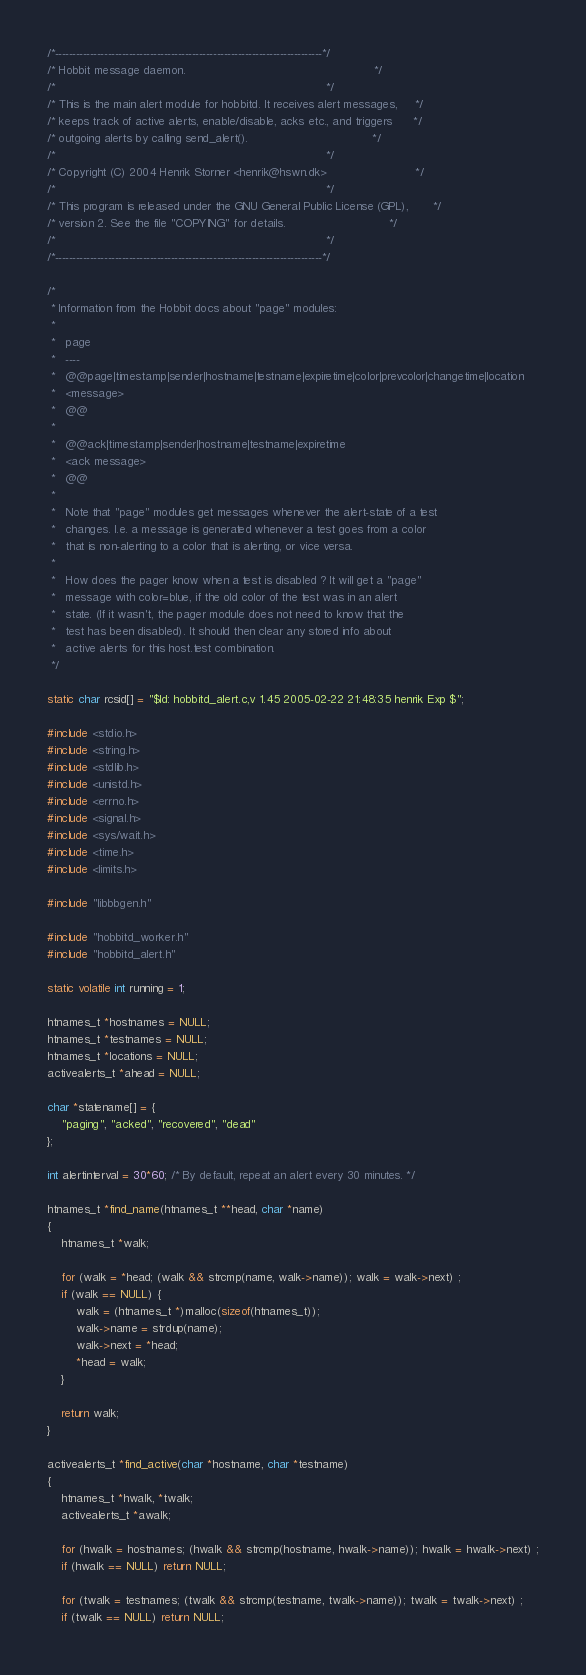Convert code to text. <code><loc_0><loc_0><loc_500><loc_500><_C_>/*----------------------------------------------------------------------------*/
/* Hobbit message daemon.                                                     */
/*                                                                            */
/* This is the main alert module for hobbitd. It receives alert messages,     */
/* keeps track of active alerts, enable/disable, acks etc., and triggers      */
/* outgoing alerts by calling send_alert().                                   */
/*                                                                            */
/* Copyright (C) 2004 Henrik Storner <henrik@hswn.dk>                         */
/*                                                                            */
/* This program is released under the GNU General Public License (GPL),       */
/* version 2. See the file "COPYING" for details.                             */
/*                                                                            */
/*----------------------------------------------------------------------------*/

/*
 * Information from the Hobbit docs about "page" modules:
 *
 *   page
 *   ----
 *   @@page|timestamp|sender|hostname|testname|expiretime|color|prevcolor|changetime|location
 *   <message>
 *   @@
 *
 *   @@ack|timestamp|sender|hostname|testname|expiretime
 *   <ack message>
 *   @@
 *
 *   Note that "page" modules get messages whenever the alert-state of a test
 *   changes. I.e. a message is generated whenever a test goes from a color
 *   that is non-alerting to a color that is alerting, or vice versa.
 *
 *   How does the pager know when a test is disabled ? It will get a "page"
 *   message with color=blue, if the old color of the test was in an alert
 *   state. (If it wasn't, the pager module does not need to know that the
 *   test has been disabled). It should then clear any stored info about
 *   active alerts for this host.test combination.
 */

static char rcsid[] = "$Id: hobbitd_alert.c,v 1.45 2005-02-22 21:48:35 henrik Exp $";

#include <stdio.h>
#include <string.h>
#include <stdlib.h>
#include <unistd.h>
#include <errno.h>
#include <signal.h>
#include <sys/wait.h>
#include <time.h>
#include <limits.h>

#include "libbbgen.h"

#include "hobbitd_worker.h"
#include "hobbitd_alert.h"

static volatile int running = 1;

htnames_t *hostnames = NULL;
htnames_t *testnames = NULL;
htnames_t *locations = NULL;
activealerts_t *ahead = NULL;

char *statename[] = {
	"paging", "acked", "recovered", "dead"
};

int alertinterval = 30*60; /* By default, repeat an alert every 30 minutes. */

htnames_t *find_name(htnames_t **head, char *name)
{
	htnames_t *walk;

	for (walk = *head; (walk && strcmp(name, walk->name)); walk = walk->next) ;
	if (walk == NULL) {
		walk = (htnames_t *)malloc(sizeof(htnames_t));
		walk->name = strdup(name);
		walk->next = *head;
		*head = walk;
	}

	return walk;
}

activealerts_t *find_active(char *hostname, char *testname)
{
	htnames_t *hwalk, *twalk;
	activealerts_t *awalk;

	for (hwalk = hostnames; (hwalk && strcmp(hostname, hwalk->name)); hwalk = hwalk->next) ;
	if (hwalk == NULL) return NULL;

	for (twalk = testnames; (twalk && strcmp(testname, twalk->name)); twalk = twalk->next) ;
	if (twalk == NULL) return NULL;
</code> 